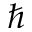Convert formula to latex. <formula><loc_0><loc_0><loc_500><loc_500>\hbar</formula> 